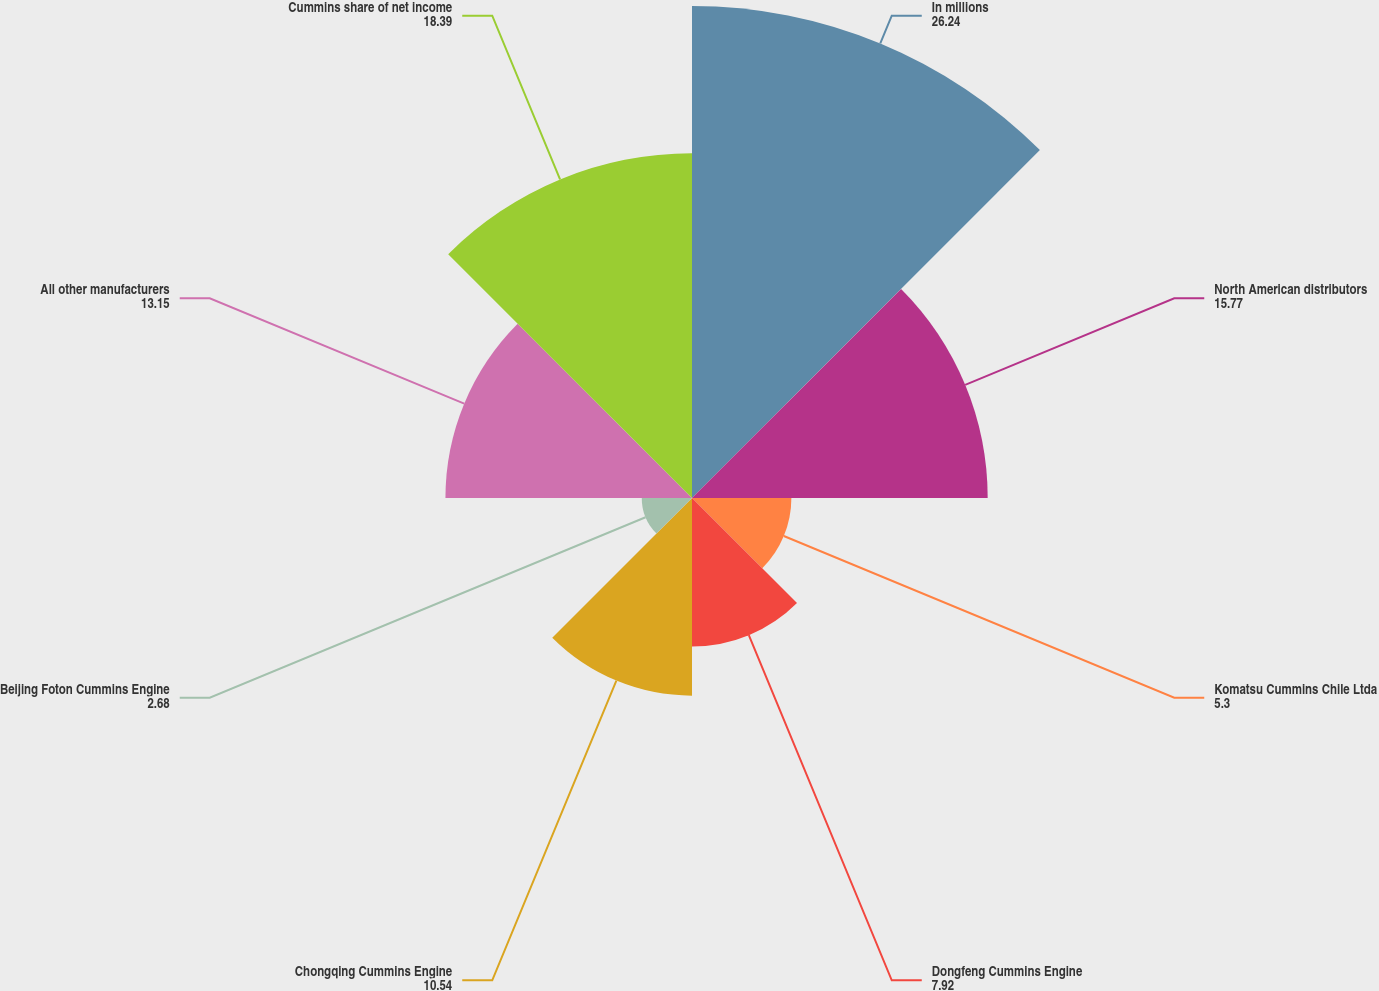<chart> <loc_0><loc_0><loc_500><loc_500><pie_chart><fcel>In millions<fcel>North American distributors<fcel>Komatsu Cummins Chile Ltda<fcel>Dongfeng Cummins Engine<fcel>Chongqing Cummins Engine<fcel>Beijing Foton Cummins Engine<fcel>All other manufacturers<fcel>Cummins share of net income<nl><fcel>26.24%<fcel>15.77%<fcel>5.3%<fcel>7.92%<fcel>10.54%<fcel>2.68%<fcel>13.15%<fcel>18.39%<nl></chart> 